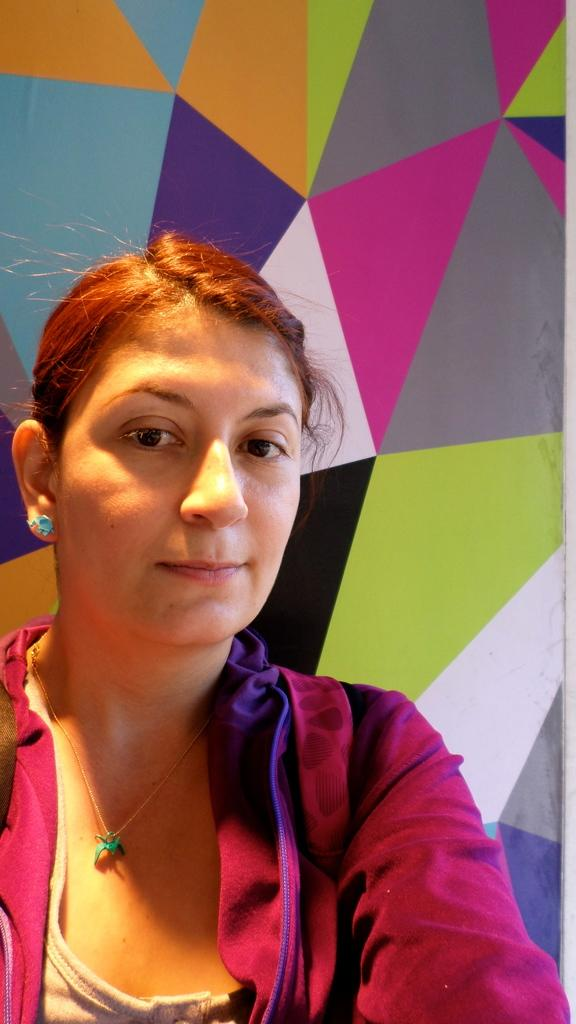Who is present in the image? There is a woman in the image. What is the woman's expression? The woman is smiling. What can be seen in the background of the image? There is a wall in the background of the image. What type of plantation can be seen in the image? There is no plantation present in the image; it features a woman smiling with a wall in the background. What sound does the thunder make in the image? There is no thunder present in the image, as it only features a woman smiling and a wall in the background. 